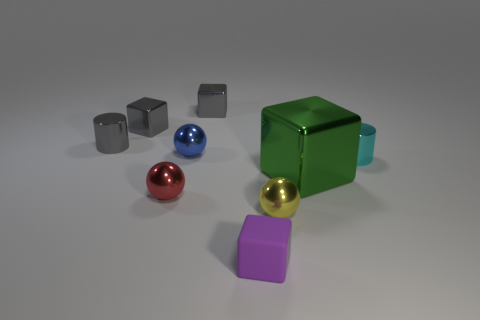There is a tiny object that is to the right of the yellow shiny object; what shape is it?
Provide a short and direct response. Cylinder. What number of red things have the same size as the green shiny thing?
Give a very brief answer. 0. The matte object is what color?
Make the answer very short. Purple. There is a big metallic cube; does it have the same color as the metallic cylinder that is to the left of the purple object?
Your response must be concise. No. What is the size of the red thing that is the same material as the tiny cyan thing?
Offer a very short reply. Small. Is there another shiny object that has the same color as the big object?
Give a very brief answer. No. What number of objects are things that are right of the small matte block or yellow shiny cubes?
Your response must be concise. 3. Does the cyan cylinder have the same material as the ball right of the purple matte cube?
Keep it short and to the point. Yes. Are there any small cyan balls made of the same material as the cyan cylinder?
Offer a terse response. No. What number of things are either balls behind the big block or shiny objects that are behind the small blue metal sphere?
Provide a short and direct response. 4. 